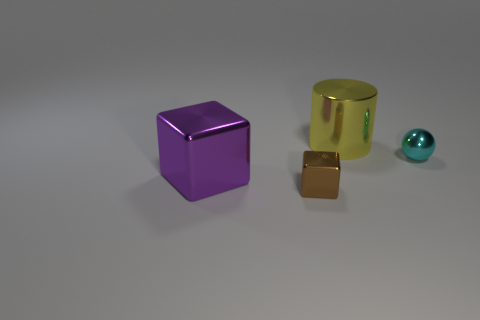Add 4 red shiny blocks. How many objects exist? 8 Subtract all cylinders. How many objects are left? 3 Subtract 1 purple blocks. How many objects are left? 3 Subtract all yellow metal objects. Subtract all large gray cylinders. How many objects are left? 3 Add 4 yellow things. How many yellow things are left? 5 Add 2 big things. How many big things exist? 4 